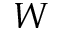<formula> <loc_0><loc_0><loc_500><loc_500>W</formula> 